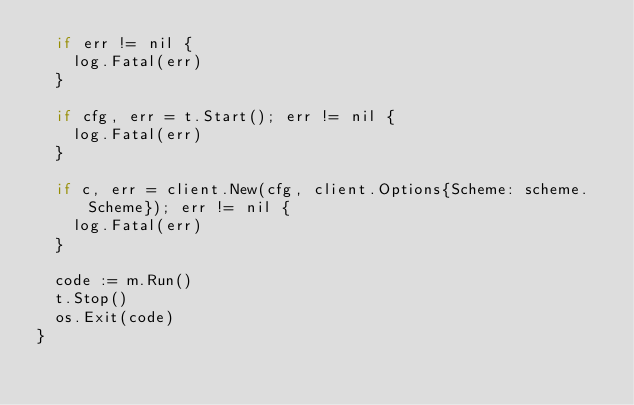<code> <loc_0><loc_0><loc_500><loc_500><_Go_>	if err != nil {
		log.Fatal(err)
	}

	if cfg, err = t.Start(); err != nil {
		log.Fatal(err)
	}

	if c, err = client.New(cfg, client.Options{Scheme: scheme.Scheme}); err != nil {
		log.Fatal(err)
	}

	code := m.Run()
	t.Stop()
	os.Exit(code)
}
</code> 